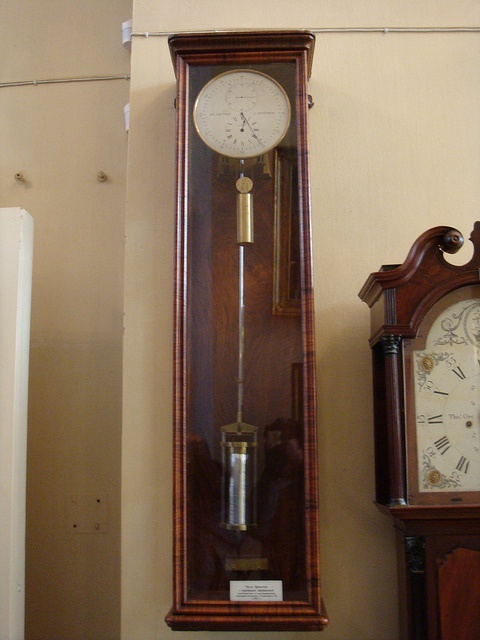Describe the objects in this image and their specific colors. I can see clock in tan, black, maroon, and gray tones and clock in tan, darkgray, and gray tones in this image. 